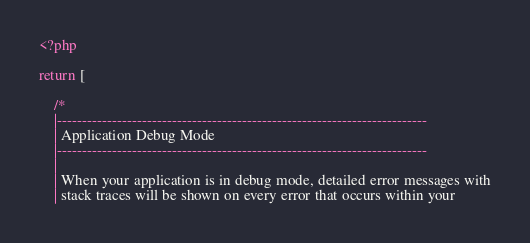Convert code to text. <code><loc_0><loc_0><loc_500><loc_500><_PHP_><?php

return [

    /*
    |--------------------------------------------------------------------------
    | Application Debug Mode
    |--------------------------------------------------------------------------
    |
    | When your application is in debug mode, detailed error messages with
    | stack traces will be shown on every error that occurs within your</code> 